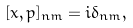Convert formula to latex. <formula><loc_0><loc_0><loc_500><loc_500>[ x , p ] _ { n m } = i \delta _ { n m } ,</formula> 